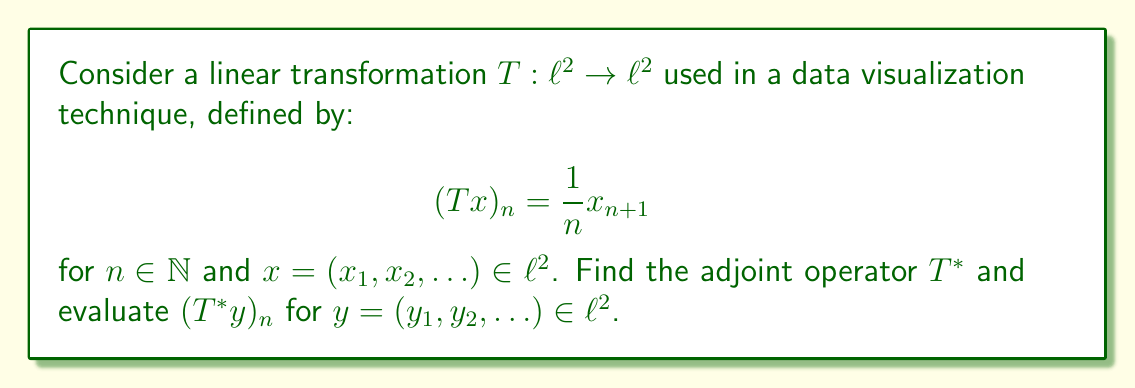Can you answer this question? To find the adjoint operator $T^*$, we need to satisfy the condition:

$$\langle Tx, y \rangle = \langle x, T^*y \rangle$$

for all $x, y \in \ell^2$. Let's proceed step-by-step:

1) First, let's calculate the left-hand side:

   $$\langle Tx, y \rangle = \sum_{n=1}^{\infty} (Tx)_n \overline{y_n} = \sum_{n=1}^{\infty} \frac{1}{n} x_{n+1} \overline{y_n}$$

2) Now, let's consider the right-hand side:

   $$\langle x, T^*y \rangle = \sum_{n=1}^{\infty} x_n \overline{(T^*y)_n}$$

3) For these to be equal for all $x$ and $y$, we must have:

   $$x_{n+1} \cdot \frac{1}{n} \overline{y_n} = x_n \cdot \overline{(T^*y)_n}$$

4) This implies:

   $$(T^*y)_n = \frac{1}{n-1} y_{n-1}$$

   for $n \geq 2$. 

5) For $n = 1$, we need to define $(T^*y)_1 = 0$ to ensure that $T^*y \in \ell^2$.

Therefore, the adjoint operator $T^*$ is defined as:

$$(T^*y)_n = \begin{cases} 
0 & \text{if } n = 1 \\
\frac{1}{n-1} y_{n-1} & \text{if } n \geq 2
\end{cases}$$

This operator shifts the sequence to the right, multiplies by the reciprocal of the new index minus one, and sets the first term to zero.
Answer: The adjoint operator $T^*: \ell^2 \rightarrow \ell^2$ is defined as:

$$(T^*y)_n = \begin{cases} 
0 & \text{if } n = 1 \\
\frac{1}{n-1} y_{n-1} & \text{if } n \geq 2
\end{cases}$$

for $y = (y_1, y_2, \ldots) \in \ell^2$. 